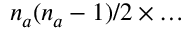<formula> <loc_0><loc_0><loc_500><loc_500>n _ { a } ( n _ { a } - 1 ) / 2 \times \dots</formula> 